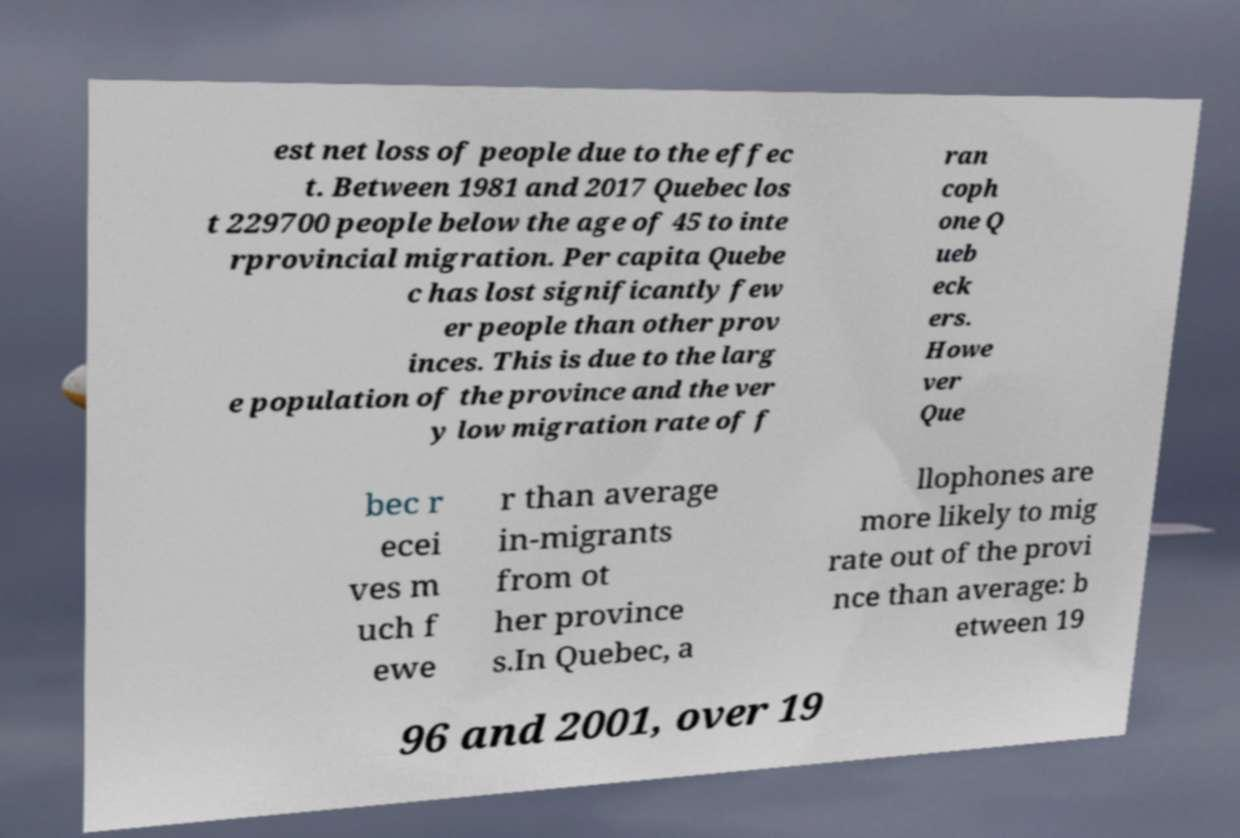Please identify and transcribe the text found in this image. est net loss of people due to the effec t. Between 1981 and 2017 Quebec los t 229700 people below the age of 45 to inte rprovincial migration. Per capita Quebe c has lost significantly few er people than other prov inces. This is due to the larg e population of the province and the ver y low migration rate of f ran coph one Q ueb eck ers. Howe ver Que bec r ecei ves m uch f ewe r than average in-migrants from ot her province s.In Quebec, a llophones are more likely to mig rate out of the provi nce than average: b etween 19 96 and 2001, over 19 